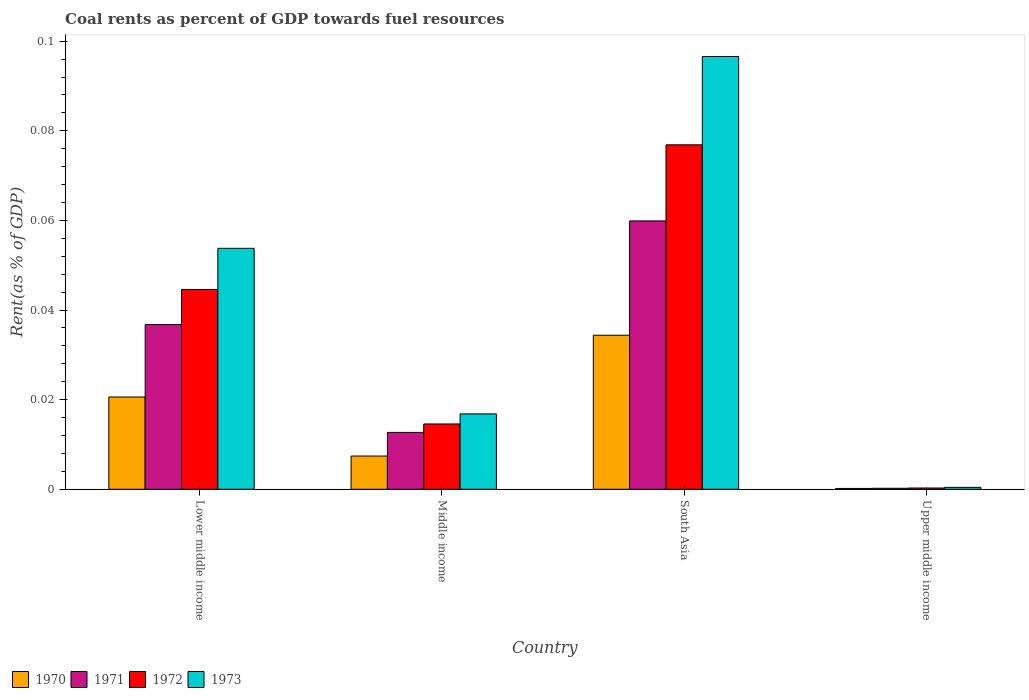How many different coloured bars are there?
Offer a terse response. 4. Are the number of bars per tick equal to the number of legend labels?
Make the answer very short. Yes. Are the number of bars on each tick of the X-axis equal?
Offer a very short reply. Yes. How many bars are there on the 3rd tick from the left?
Make the answer very short. 4. What is the label of the 1st group of bars from the left?
Provide a succinct answer. Lower middle income. In how many cases, is the number of bars for a given country not equal to the number of legend labels?
Your response must be concise. 0. What is the coal rent in 1970 in Middle income?
Your response must be concise. 0.01. Across all countries, what is the maximum coal rent in 1970?
Give a very brief answer. 0.03. Across all countries, what is the minimum coal rent in 1970?
Keep it short and to the point. 0. In which country was the coal rent in 1971 maximum?
Your answer should be very brief. South Asia. In which country was the coal rent in 1973 minimum?
Offer a terse response. Upper middle income. What is the total coal rent in 1972 in the graph?
Ensure brevity in your answer.  0.14. What is the difference between the coal rent in 1970 in Lower middle income and that in South Asia?
Your answer should be compact. -0.01. What is the difference between the coal rent in 1970 in Lower middle income and the coal rent in 1972 in Upper middle income?
Your response must be concise. 0.02. What is the average coal rent in 1972 per country?
Your answer should be very brief. 0.03. What is the difference between the coal rent of/in 1972 and coal rent of/in 1970 in Upper middle income?
Provide a succinct answer. 0. What is the ratio of the coal rent in 1971 in Lower middle income to that in Upper middle income?
Ensure brevity in your answer.  167.98. Is the difference between the coal rent in 1972 in Lower middle income and Upper middle income greater than the difference between the coal rent in 1970 in Lower middle income and Upper middle income?
Offer a terse response. Yes. What is the difference between the highest and the second highest coal rent in 1971?
Give a very brief answer. 0.05. What is the difference between the highest and the lowest coal rent in 1972?
Your answer should be compact. 0.08. In how many countries, is the coal rent in 1973 greater than the average coal rent in 1973 taken over all countries?
Make the answer very short. 2. Is the sum of the coal rent in 1973 in South Asia and Upper middle income greater than the maximum coal rent in 1971 across all countries?
Your answer should be compact. Yes. What does the 2nd bar from the left in Middle income represents?
Ensure brevity in your answer.  1971. What does the 1st bar from the right in South Asia represents?
Your response must be concise. 1973. How many bars are there?
Your response must be concise. 16. Are all the bars in the graph horizontal?
Provide a short and direct response. No. How many countries are there in the graph?
Keep it short and to the point. 4. What is the difference between two consecutive major ticks on the Y-axis?
Ensure brevity in your answer.  0.02. Are the values on the major ticks of Y-axis written in scientific E-notation?
Give a very brief answer. No. Does the graph contain any zero values?
Ensure brevity in your answer.  No. Where does the legend appear in the graph?
Your answer should be very brief. Bottom left. How are the legend labels stacked?
Give a very brief answer. Horizontal. What is the title of the graph?
Provide a short and direct response. Coal rents as percent of GDP towards fuel resources. What is the label or title of the X-axis?
Your response must be concise. Country. What is the label or title of the Y-axis?
Your response must be concise. Rent(as % of GDP). What is the Rent(as % of GDP) of 1970 in Lower middle income?
Offer a terse response. 0.02. What is the Rent(as % of GDP) in 1971 in Lower middle income?
Your response must be concise. 0.04. What is the Rent(as % of GDP) in 1972 in Lower middle income?
Offer a very short reply. 0.04. What is the Rent(as % of GDP) of 1973 in Lower middle income?
Offer a very short reply. 0.05. What is the Rent(as % of GDP) in 1970 in Middle income?
Provide a succinct answer. 0.01. What is the Rent(as % of GDP) of 1971 in Middle income?
Provide a short and direct response. 0.01. What is the Rent(as % of GDP) of 1972 in Middle income?
Make the answer very short. 0.01. What is the Rent(as % of GDP) in 1973 in Middle income?
Ensure brevity in your answer.  0.02. What is the Rent(as % of GDP) in 1970 in South Asia?
Ensure brevity in your answer.  0.03. What is the Rent(as % of GDP) in 1971 in South Asia?
Ensure brevity in your answer.  0.06. What is the Rent(as % of GDP) in 1972 in South Asia?
Your answer should be compact. 0.08. What is the Rent(as % of GDP) of 1973 in South Asia?
Your answer should be compact. 0.1. What is the Rent(as % of GDP) of 1970 in Upper middle income?
Your response must be concise. 0. What is the Rent(as % of GDP) of 1971 in Upper middle income?
Make the answer very short. 0. What is the Rent(as % of GDP) in 1972 in Upper middle income?
Your answer should be very brief. 0. What is the Rent(as % of GDP) in 1973 in Upper middle income?
Offer a terse response. 0. Across all countries, what is the maximum Rent(as % of GDP) of 1970?
Your response must be concise. 0.03. Across all countries, what is the maximum Rent(as % of GDP) of 1971?
Your answer should be compact. 0.06. Across all countries, what is the maximum Rent(as % of GDP) in 1972?
Give a very brief answer. 0.08. Across all countries, what is the maximum Rent(as % of GDP) of 1973?
Your response must be concise. 0.1. Across all countries, what is the minimum Rent(as % of GDP) in 1970?
Give a very brief answer. 0. Across all countries, what is the minimum Rent(as % of GDP) in 1971?
Ensure brevity in your answer.  0. Across all countries, what is the minimum Rent(as % of GDP) of 1972?
Make the answer very short. 0. Across all countries, what is the minimum Rent(as % of GDP) of 1973?
Make the answer very short. 0. What is the total Rent(as % of GDP) in 1970 in the graph?
Give a very brief answer. 0.06. What is the total Rent(as % of GDP) of 1971 in the graph?
Ensure brevity in your answer.  0.11. What is the total Rent(as % of GDP) of 1972 in the graph?
Make the answer very short. 0.14. What is the total Rent(as % of GDP) of 1973 in the graph?
Your answer should be compact. 0.17. What is the difference between the Rent(as % of GDP) of 1970 in Lower middle income and that in Middle income?
Your response must be concise. 0.01. What is the difference between the Rent(as % of GDP) of 1971 in Lower middle income and that in Middle income?
Ensure brevity in your answer.  0.02. What is the difference between the Rent(as % of GDP) in 1972 in Lower middle income and that in Middle income?
Give a very brief answer. 0.03. What is the difference between the Rent(as % of GDP) in 1973 in Lower middle income and that in Middle income?
Keep it short and to the point. 0.04. What is the difference between the Rent(as % of GDP) in 1970 in Lower middle income and that in South Asia?
Keep it short and to the point. -0.01. What is the difference between the Rent(as % of GDP) of 1971 in Lower middle income and that in South Asia?
Give a very brief answer. -0.02. What is the difference between the Rent(as % of GDP) in 1972 in Lower middle income and that in South Asia?
Give a very brief answer. -0.03. What is the difference between the Rent(as % of GDP) in 1973 in Lower middle income and that in South Asia?
Provide a short and direct response. -0.04. What is the difference between the Rent(as % of GDP) in 1970 in Lower middle income and that in Upper middle income?
Provide a short and direct response. 0.02. What is the difference between the Rent(as % of GDP) in 1971 in Lower middle income and that in Upper middle income?
Provide a succinct answer. 0.04. What is the difference between the Rent(as % of GDP) of 1972 in Lower middle income and that in Upper middle income?
Your answer should be compact. 0.04. What is the difference between the Rent(as % of GDP) of 1973 in Lower middle income and that in Upper middle income?
Make the answer very short. 0.05. What is the difference between the Rent(as % of GDP) of 1970 in Middle income and that in South Asia?
Provide a succinct answer. -0.03. What is the difference between the Rent(as % of GDP) of 1971 in Middle income and that in South Asia?
Give a very brief answer. -0.05. What is the difference between the Rent(as % of GDP) of 1972 in Middle income and that in South Asia?
Offer a very short reply. -0.06. What is the difference between the Rent(as % of GDP) in 1973 in Middle income and that in South Asia?
Offer a very short reply. -0.08. What is the difference between the Rent(as % of GDP) of 1970 in Middle income and that in Upper middle income?
Provide a short and direct response. 0.01. What is the difference between the Rent(as % of GDP) of 1971 in Middle income and that in Upper middle income?
Provide a short and direct response. 0.01. What is the difference between the Rent(as % of GDP) of 1972 in Middle income and that in Upper middle income?
Your answer should be very brief. 0.01. What is the difference between the Rent(as % of GDP) of 1973 in Middle income and that in Upper middle income?
Ensure brevity in your answer.  0.02. What is the difference between the Rent(as % of GDP) of 1970 in South Asia and that in Upper middle income?
Your answer should be compact. 0.03. What is the difference between the Rent(as % of GDP) in 1971 in South Asia and that in Upper middle income?
Provide a succinct answer. 0.06. What is the difference between the Rent(as % of GDP) in 1972 in South Asia and that in Upper middle income?
Provide a short and direct response. 0.08. What is the difference between the Rent(as % of GDP) of 1973 in South Asia and that in Upper middle income?
Offer a terse response. 0.1. What is the difference between the Rent(as % of GDP) in 1970 in Lower middle income and the Rent(as % of GDP) in 1971 in Middle income?
Offer a very short reply. 0.01. What is the difference between the Rent(as % of GDP) in 1970 in Lower middle income and the Rent(as % of GDP) in 1972 in Middle income?
Your answer should be compact. 0.01. What is the difference between the Rent(as % of GDP) in 1970 in Lower middle income and the Rent(as % of GDP) in 1973 in Middle income?
Keep it short and to the point. 0. What is the difference between the Rent(as % of GDP) in 1971 in Lower middle income and the Rent(as % of GDP) in 1972 in Middle income?
Ensure brevity in your answer.  0.02. What is the difference between the Rent(as % of GDP) of 1971 in Lower middle income and the Rent(as % of GDP) of 1973 in Middle income?
Offer a terse response. 0.02. What is the difference between the Rent(as % of GDP) of 1972 in Lower middle income and the Rent(as % of GDP) of 1973 in Middle income?
Offer a terse response. 0.03. What is the difference between the Rent(as % of GDP) of 1970 in Lower middle income and the Rent(as % of GDP) of 1971 in South Asia?
Offer a very short reply. -0.04. What is the difference between the Rent(as % of GDP) in 1970 in Lower middle income and the Rent(as % of GDP) in 1972 in South Asia?
Your answer should be compact. -0.06. What is the difference between the Rent(as % of GDP) of 1970 in Lower middle income and the Rent(as % of GDP) of 1973 in South Asia?
Make the answer very short. -0.08. What is the difference between the Rent(as % of GDP) in 1971 in Lower middle income and the Rent(as % of GDP) in 1972 in South Asia?
Your answer should be very brief. -0.04. What is the difference between the Rent(as % of GDP) of 1971 in Lower middle income and the Rent(as % of GDP) of 1973 in South Asia?
Provide a short and direct response. -0.06. What is the difference between the Rent(as % of GDP) in 1972 in Lower middle income and the Rent(as % of GDP) in 1973 in South Asia?
Your response must be concise. -0.05. What is the difference between the Rent(as % of GDP) in 1970 in Lower middle income and the Rent(as % of GDP) in 1971 in Upper middle income?
Give a very brief answer. 0.02. What is the difference between the Rent(as % of GDP) in 1970 in Lower middle income and the Rent(as % of GDP) in 1972 in Upper middle income?
Your answer should be compact. 0.02. What is the difference between the Rent(as % of GDP) of 1970 in Lower middle income and the Rent(as % of GDP) of 1973 in Upper middle income?
Ensure brevity in your answer.  0.02. What is the difference between the Rent(as % of GDP) in 1971 in Lower middle income and the Rent(as % of GDP) in 1972 in Upper middle income?
Your answer should be compact. 0.04. What is the difference between the Rent(as % of GDP) in 1971 in Lower middle income and the Rent(as % of GDP) in 1973 in Upper middle income?
Your response must be concise. 0.04. What is the difference between the Rent(as % of GDP) in 1972 in Lower middle income and the Rent(as % of GDP) in 1973 in Upper middle income?
Ensure brevity in your answer.  0.04. What is the difference between the Rent(as % of GDP) of 1970 in Middle income and the Rent(as % of GDP) of 1971 in South Asia?
Keep it short and to the point. -0.05. What is the difference between the Rent(as % of GDP) of 1970 in Middle income and the Rent(as % of GDP) of 1972 in South Asia?
Provide a short and direct response. -0.07. What is the difference between the Rent(as % of GDP) in 1970 in Middle income and the Rent(as % of GDP) in 1973 in South Asia?
Provide a succinct answer. -0.09. What is the difference between the Rent(as % of GDP) in 1971 in Middle income and the Rent(as % of GDP) in 1972 in South Asia?
Offer a very short reply. -0.06. What is the difference between the Rent(as % of GDP) in 1971 in Middle income and the Rent(as % of GDP) in 1973 in South Asia?
Make the answer very short. -0.08. What is the difference between the Rent(as % of GDP) of 1972 in Middle income and the Rent(as % of GDP) of 1973 in South Asia?
Give a very brief answer. -0.08. What is the difference between the Rent(as % of GDP) in 1970 in Middle income and the Rent(as % of GDP) in 1971 in Upper middle income?
Offer a terse response. 0.01. What is the difference between the Rent(as % of GDP) of 1970 in Middle income and the Rent(as % of GDP) of 1972 in Upper middle income?
Provide a short and direct response. 0.01. What is the difference between the Rent(as % of GDP) of 1970 in Middle income and the Rent(as % of GDP) of 1973 in Upper middle income?
Provide a short and direct response. 0.01. What is the difference between the Rent(as % of GDP) of 1971 in Middle income and the Rent(as % of GDP) of 1972 in Upper middle income?
Provide a short and direct response. 0.01. What is the difference between the Rent(as % of GDP) of 1971 in Middle income and the Rent(as % of GDP) of 1973 in Upper middle income?
Provide a succinct answer. 0.01. What is the difference between the Rent(as % of GDP) in 1972 in Middle income and the Rent(as % of GDP) in 1973 in Upper middle income?
Your response must be concise. 0.01. What is the difference between the Rent(as % of GDP) in 1970 in South Asia and the Rent(as % of GDP) in 1971 in Upper middle income?
Your response must be concise. 0.03. What is the difference between the Rent(as % of GDP) of 1970 in South Asia and the Rent(as % of GDP) of 1972 in Upper middle income?
Your response must be concise. 0.03. What is the difference between the Rent(as % of GDP) in 1970 in South Asia and the Rent(as % of GDP) in 1973 in Upper middle income?
Provide a short and direct response. 0.03. What is the difference between the Rent(as % of GDP) in 1971 in South Asia and the Rent(as % of GDP) in 1972 in Upper middle income?
Your response must be concise. 0.06. What is the difference between the Rent(as % of GDP) of 1971 in South Asia and the Rent(as % of GDP) of 1973 in Upper middle income?
Your answer should be very brief. 0.06. What is the difference between the Rent(as % of GDP) in 1972 in South Asia and the Rent(as % of GDP) in 1973 in Upper middle income?
Offer a very short reply. 0.08. What is the average Rent(as % of GDP) in 1970 per country?
Offer a very short reply. 0.02. What is the average Rent(as % of GDP) in 1971 per country?
Provide a succinct answer. 0.03. What is the average Rent(as % of GDP) in 1972 per country?
Keep it short and to the point. 0.03. What is the average Rent(as % of GDP) in 1973 per country?
Offer a terse response. 0.04. What is the difference between the Rent(as % of GDP) in 1970 and Rent(as % of GDP) in 1971 in Lower middle income?
Make the answer very short. -0.02. What is the difference between the Rent(as % of GDP) of 1970 and Rent(as % of GDP) of 1972 in Lower middle income?
Keep it short and to the point. -0.02. What is the difference between the Rent(as % of GDP) in 1970 and Rent(as % of GDP) in 1973 in Lower middle income?
Give a very brief answer. -0.03. What is the difference between the Rent(as % of GDP) of 1971 and Rent(as % of GDP) of 1972 in Lower middle income?
Give a very brief answer. -0.01. What is the difference between the Rent(as % of GDP) in 1971 and Rent(as % of GDP) in 1973 in Lower middle income?
Offer a very short reply. -0.02. What is the difference between the Rent(as % of GDP) of 1972 and Rent(as % of GDP) of 1973 in Lower middle income?
Provide a short and direct response. -0.01. What is the difference between the Rent(as % of GDP) of 1970 and Rent(as % of GDP) of 1971 in Middle income?
Your answer should be compact. -0.01. What is the difference between the Rent(as % of GDP) of 1970 and Rent(as % of GDP) of 1972 in Middle income?
Provide a short and direct response. -0.01. What is the difference between the Rent(as % of GDP) in 1970 and Rent(as % of GDP) in 1973 in Middle income?
Ensure brevity in your answer.  -0.01. What is the difference between the Rent(as % of GDP) of 1971 and Rent(as % of GDP) of 1972 in Middle income?
Offer a terse response. -0. What is the difference between the Rent(as % of GDP) in 1971 and Rent(as % of GDP) in 1973 in Middle income?
Offer a very short reply. -0. What is the difference between the Rent(as % of GDP) in 1972 and Rent(as % of GDP) in 1973 in Middle income?
Ensure brevity in your answer.  -0. What is the difference between the Rent(as % of GDP) of 1970 and Rent(as % of GDP) of 1971 in South Asia?
Make the answer very short. -0.03. What is the difference between the Rent(as % of GDP) of 1970 and Rent(as % of GDP) of 1972 in South Asia?
Keep it short and to the point. -0.04. What is the difference between the Rent(as % of GDP) of 1970 and Rent(as % of GDP) of 1973 in South Asia?
Offer a terse response. -0.06. What is the difference between the Rent(as % of GDP) in 1971 and Rent(as % of GDP) in 1972 in South Asia?
Ensure brevity in your answer.  -0.02. What is the difference between the Rent(as % of GDP) in 1971 and Rent(as % of GDP) in 1973 in South Asia?
Give a very brief answer. -0.04. What is the difference between the Rent(as % of GDP) in 1972 and Rent(as % of GDP) in 1973 in South Asia?
Make the answer very short. -0.02. What is the difference between the Rent(as % of GDP) of 1970 and Rent(as % of GDP) of 1971 in Upper middle income?
Give a very brief answer. -0. What is the difference between the Rent(as % of GDP) in 1970 and Rent(as % of GDP) in 1972 in Upper middle income?
Give a very brief answer. -0. What is the difference between the Rent(as % of GDP) in 1970 and Rent(as % of GDP) in 1973 in Upper middle income?
Provide a short and direct response. -0. What is the difference between the Rent(as % of GDP) in 1971 and Rent(as % of GDP) in 1972 in Upper middle income?
Provide a short and direct response. -0. What is the difference between the Rent(as % of GDP) in 1971 and Rent(as % of GDP) in 1973 in Upper middle income?
Your answer should be very brief. -0. What is the difference between the Rent(as % of GDP) of 1972 and Rent(as % of GDP) of 1973 in Upper middle income?
Your response must be concise. -0. What is the ratio of the Rent(as % of GDP) of 1970 in Lower middle income to that in Middle income?
Your answer should be very brief. 2.78. What is the ratio of the Rent(as % of GDP) of 1971 in Lower middle income to that in Middle income?
Give a very brief answer. 2.9. What is the ratio of the Rent(as % of GDP) in 1972 in Lower middle income to that in Middle income?
Your answer should be very brief. 3.06. What is the ratio of the Rent(as % of GDP) of 1973 in Lower middle income to that in Middle income?
Provide a succinct answer. 3.2. What is the ratio of the Rent(as % of GDP) of 1970 in Lower middle income to that in South Asia?
Your answer should be compact. 0.6. What is the ratio of the Rent(as % of GDP) in 1971 in Lower middle income to that in South Asia?
Your answer should be very brief. 0.61. What is the ratio of the Rent(as % of GDP) in 1972 in Lower middle income to that in South Asia?
Provide a short and direct response. 0.58. What is the ratio of the Rent(as % of GDP) in 1973 in Lower middle income to that in South Asia?
Keep it short and to the point. 0.56. What is the ratio of the Rent(as % of GDP) of 1970 in Lower middle income to that in Upper middle income?
Keep it short and to the point. 112.03. What is the ratio of the Rent(as % of GDP) in 1971 in Lower middle income to that in Upper middle income?
Offer a very short reply. 167.98. What is the ratio of the Rent(as % of GDP) in 1972 in Lower middle income to that in Upper middle income?
Provide a short and direct response. 156.82. What is the ratio of the Rent(as % of GDP) of 1973 in Lower middle income to that in Upper middle income?
Your answer should be compact. 124.82. What is the ratio of the Rent(as % of GDP) of 1970 in Middle income to that in South Asia?
Ensure brevity in your answer.  0.22. What is the ratio of the Rent(as % of GDP) of 1971 in Middle income to that in South Asia?
Your answer should be very brief. 0.21. What is the ratio of the Rent(as % of GDP) in 1972 in Middle income to that in South Asia?
Keep it short and to the point. 0.19. What is the ratio of the Rent(as % of GDP) of 1973 in Middle income to that in South Asia?
Offer a very short reply. 0.17. What is the ratio of the Rent(as % of GDP) in 1970 in Middle income to that in Upper middle income?
Your response must be concise. 40.36. What is the ratio of the Rent(as % of GDP) of 1971 in Middle income to that in Upper middle income?
Ensure brevity in your answer.  58.01. What is the ratio of the Rent(as % of GDP) of 1972 in Middle income to that in Upper middle income?
Offer a terse response. 51.25. What is the ratio of the Rent(as % of GDP) in 1973 in Middle income to that in Upper middle income?
Keep it short and to the point. 39.04. What is the ratio of the Rent(as % of GDP) of 1970 in South Asia to that in Upper middle income?
Your answer should be compact. 187.05. What is the ratio of the Rent(as % of GDP) of 1971 in South Asia to that in Upper middle income?
Your answer should be compact. 273.74. What is the ratio of the Rent(as % of GDP) in 1972 in South Asia to that in Upper middle income?
Your answer should be very brief. 270.32. What is the ratio of the Rent(as % of GDP) of 1973 in South Asia to that in Upper middle income?
Offer a very short reply. 224.18. What is the difference between the highest and the second highest Rent(as % of GDP) in 1970?
Your answer should be compact. 0.01. What is the difference between the highest and the second highest Rent(as % of GDP) of 1971?
Keep it short and to the point. 0.02. What is the difference between the highest and the second highest Rent(as % of GDP) of 1972?
Offer a terse response. 0.03. What is the difference between the highest and the second highest Rent(as % of GDP) in 1973?
Keep it short and to the point. 0.04. What is the difference between the highest and the lowest Rent(as % of GDP) of 1970?
Provide a short and direct response. 0.03. What is the difference between the highest and the lowest Rent(as % of GDP) of 1971?
Provide a succinct answer. 0.06. What is the difference between the highest and the lowest Rent(as % of GDP) in 1972?
Keep it short and to the point. 0.08. What is the difference between the highest and the lowest Rent(as % of GDP) of 1973?
Give a very brief answer. 0.1. 